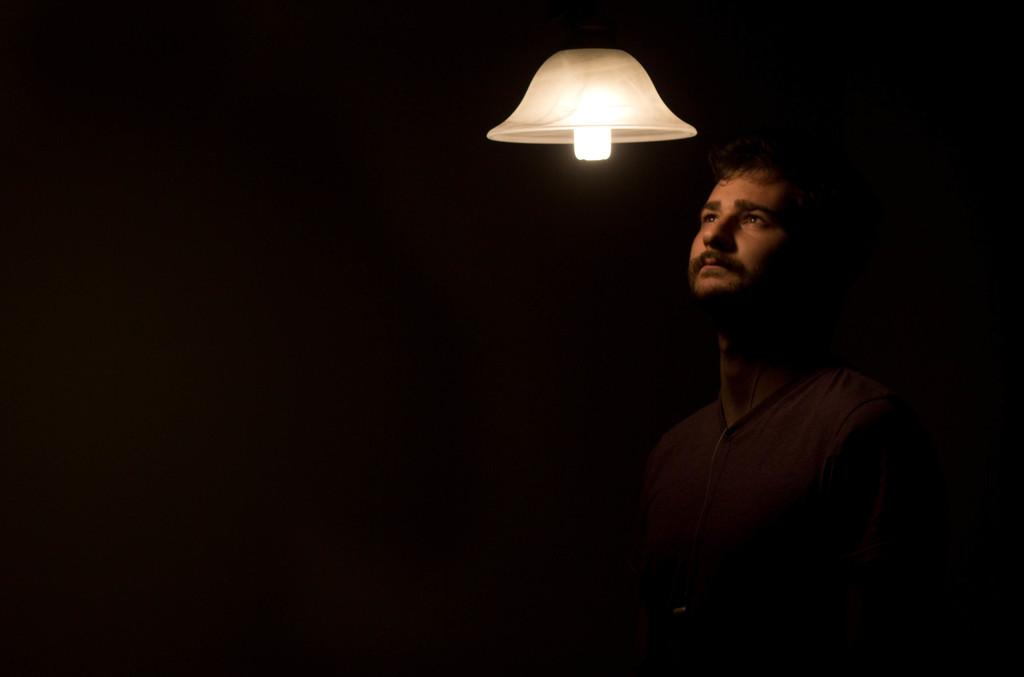What is the main subject of the image? There is a man in the image. What is the man doing in the image? The man is standing. What is the man wearing in the image? The man is wearing a black T-shirt and a brown T-shirt. What object can be seen in the image besides the man? There is a lamp in the image. How would you describe the lighting in the image? The image is set in a dark environment. What type of oatmeal is the man eating in the image? There is no oatmeal present in the image; the man is wearing a black and a brown T-shirt while standing. What rhythm is the man tapping out with his finger in the image? There is no finger tapping or rhythm present in the image; the man is simply standing and wearing two different colored T-shirts. 